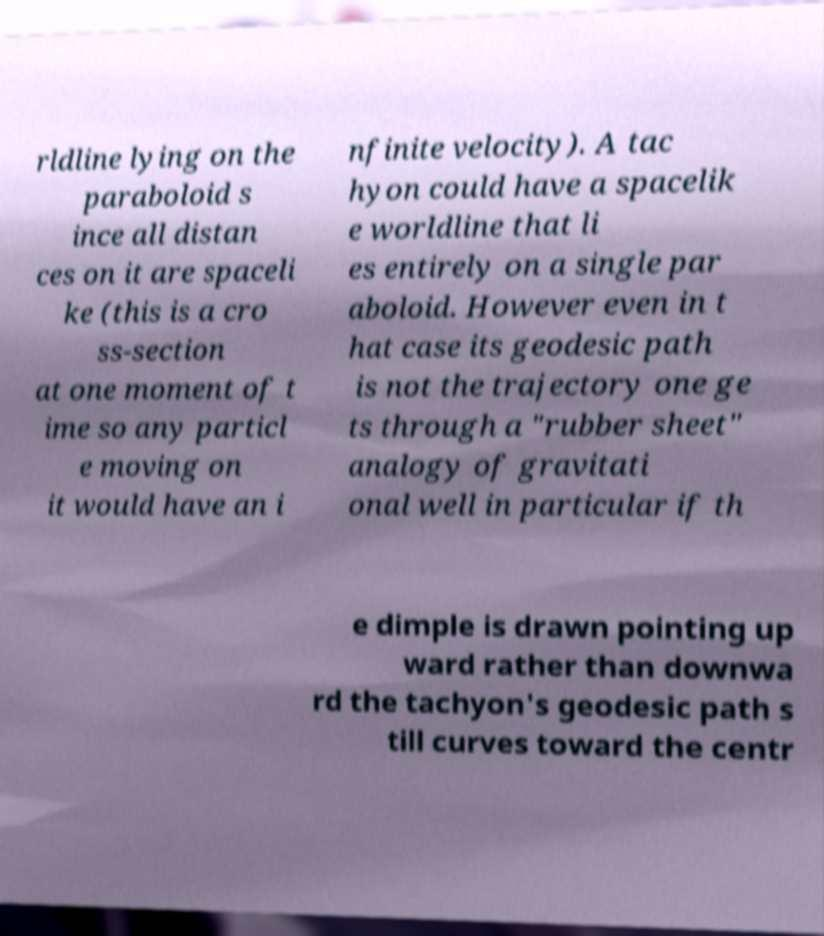Can you read and provide the text displayed in the image?This photo seems to have some interesting text. Can you extract and type it out for me? rldline lying on the paraboloid s ince all distan ces on it are spaceli ke (this is a cro ss-section at one moment of t ime so any particl e moving on it would have an i nfinite velocity). A tac hyon could have a spacelik e worldline that li es entirely on a single par aboloid. However even in t hat case its geodesic path is not the trajectory one ge ts through a "rubber sheet" analogy of gravitati onal well in particular if th e dimple is drawn pointing up ward rather than downwa rd the tachyon's geodesic path s till curves toward the centr 